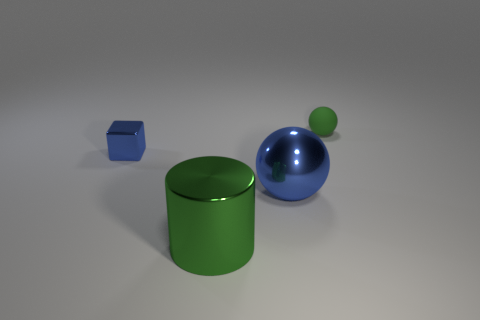If I were to place these objects in order by volume, starting with the one with the least volume, what would that order be? Starting with the least volume, the order would be: the small green sphere, the blue block, the green cylinder, and finally the large blue sphere having the most volume. 